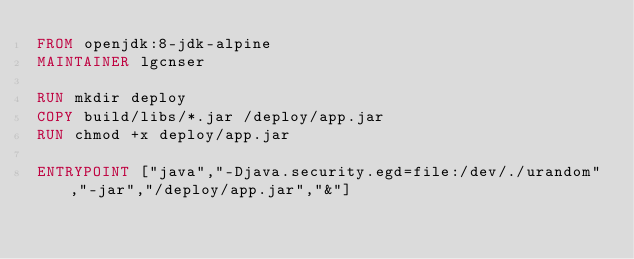<code> <loc_0><loc_0><loc_500><loc_500><_Dockerfile_>FROM openjdk:8-jdk-alpine
MAINTAINER lgcnser

RUN mkdir deploy
COPY build/libs/*.jar /deploy/app.jar
RUN chmod +x deploy/app.jar

ENTRYPOINT ["java","-Djava.security.egd=file:/dev/./urandom","-jar","/deploy/app.jar","&"]
</code> 